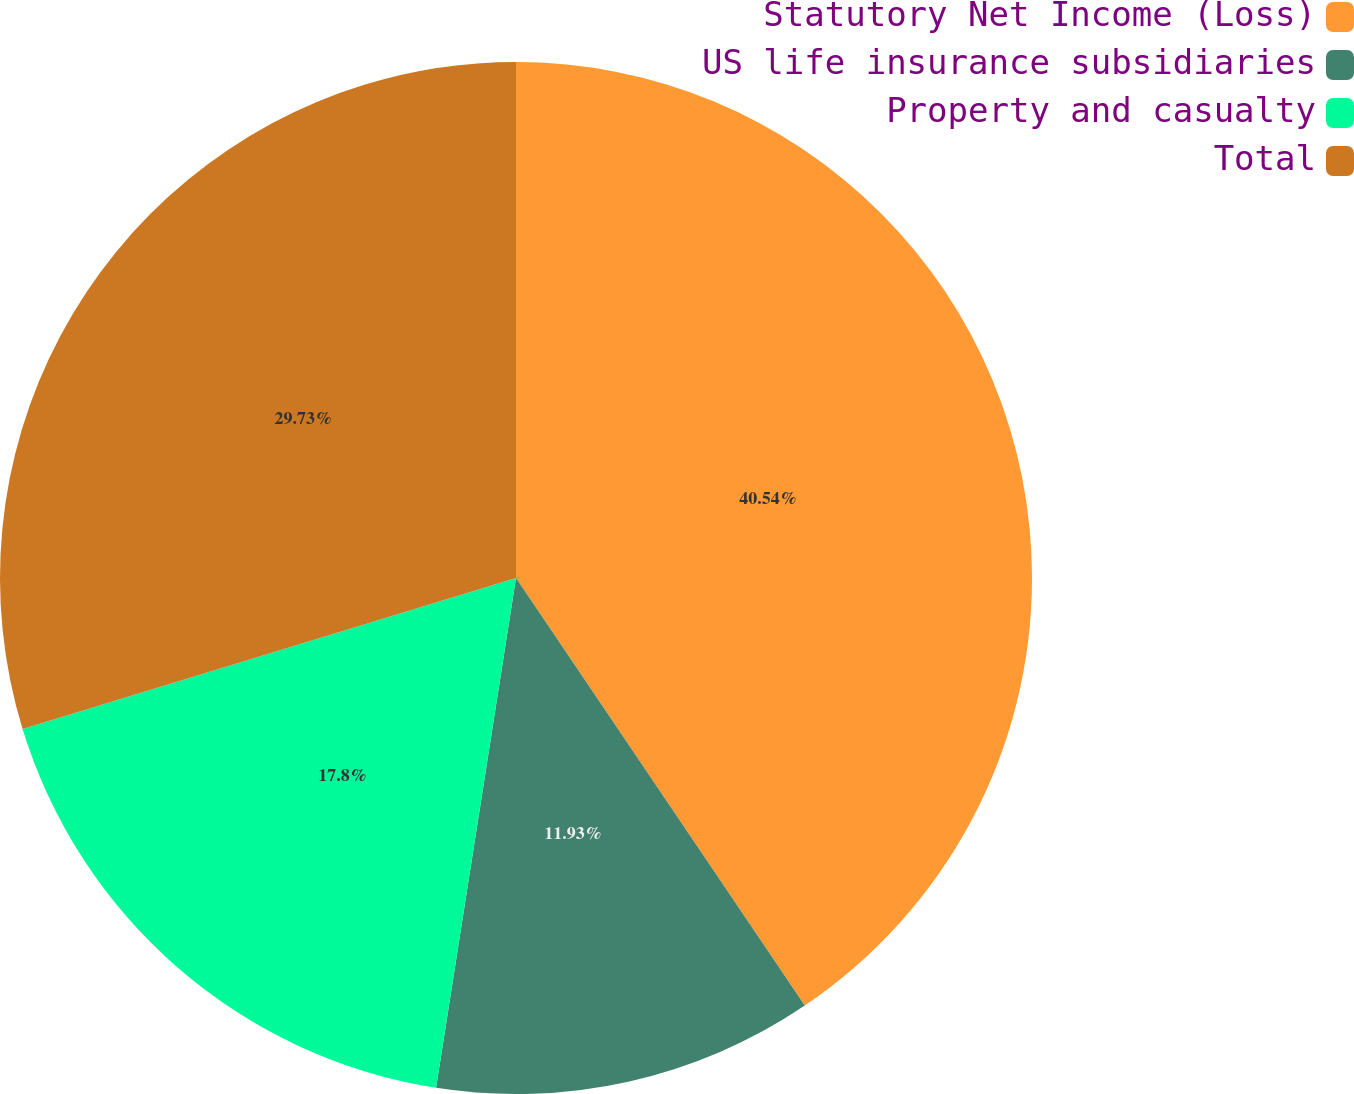<chart> <loc_0><loc_0><loc_500><loc_500><pie_chart><fcel>Statutory Net Income (Loss)<fcel>US life insurance subsidiaries<fcel>Property and casualty<fcel>Total<nl><fcel>40.55%<fcel>11.93%<fcel>17.8%<fcel>29.73%<nl></chart> 